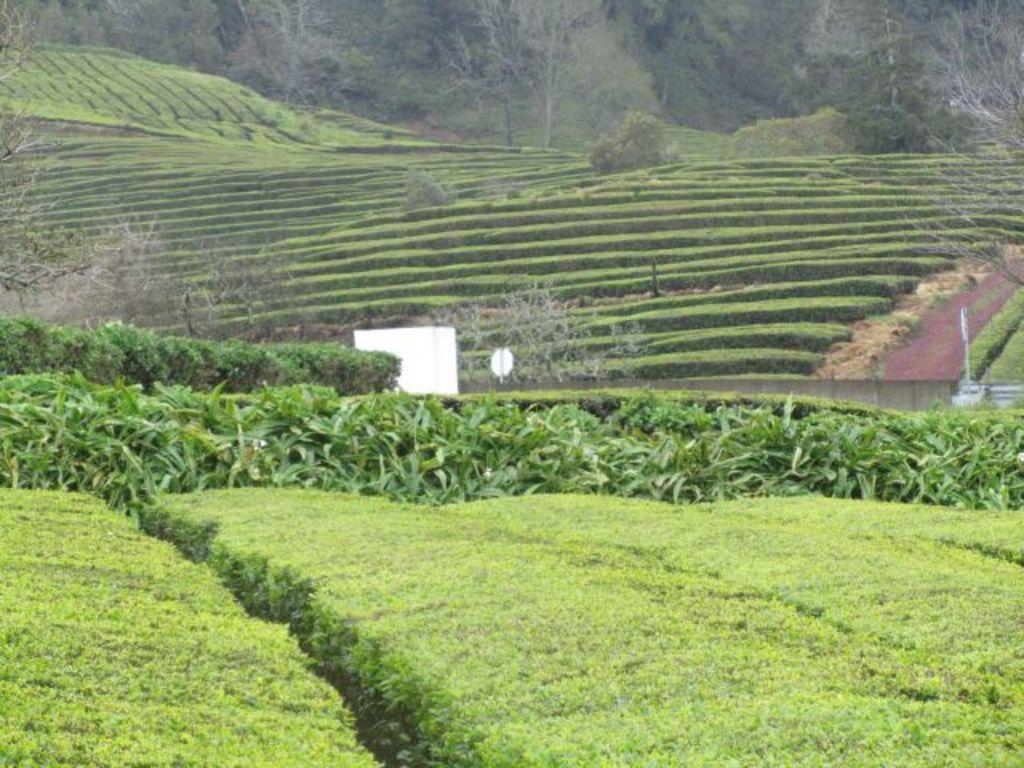Can you describe this image briefly? In this picture we can see a few plants, bushes, trees and other objects. 